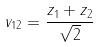Convert formula to latex. <formula><loc_0><loc_0><loc_500><loc_500>v _ { 1 2 } = \frac { z _ { 1 } + z _ { 2 } } { \sqrt { 2 } }</formula> 